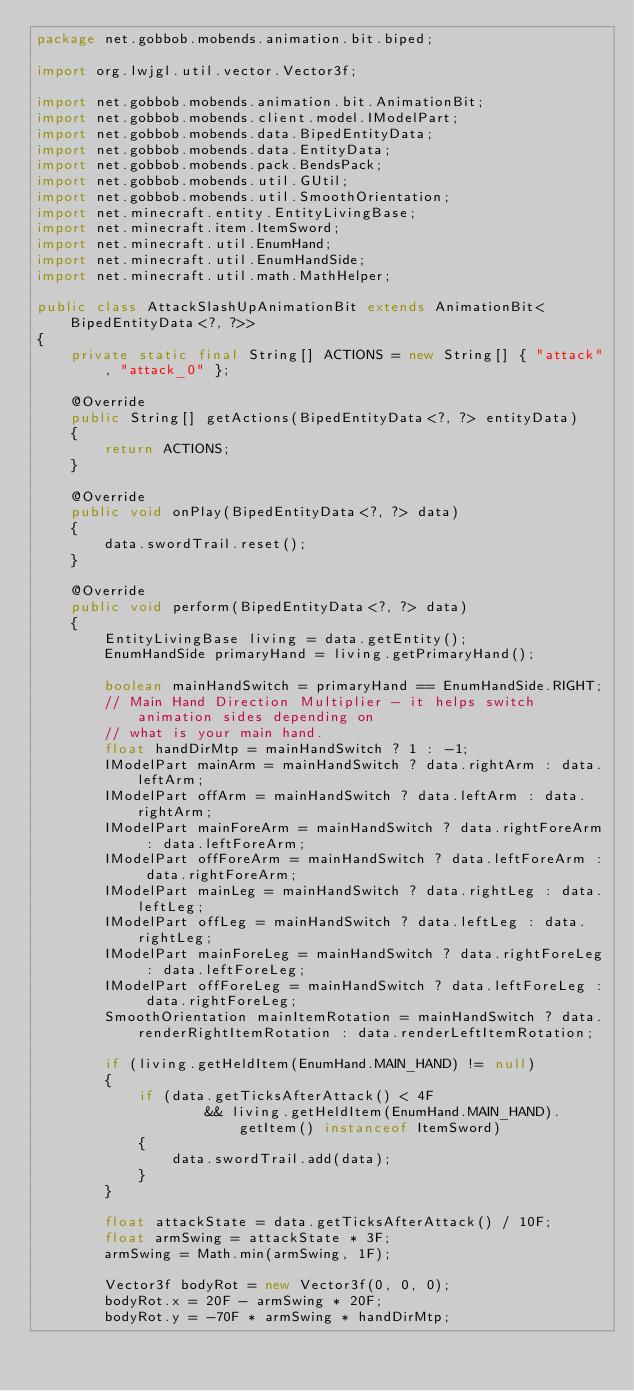<code> <loc_0><loc_0><loc_500><loc_500><_Java_>package net.gobbob.mobends.animation.bit.biped;

import org.lwjgl.util.vector.Vector3f;

import net.gobbob.mobends.animation.bit.AnimationBit;
import net.gobbob.mobends.client.model.IModelPart;
import net.gobbob.mobends.data.BipedEntityData;
import net.gobbob.mobends.data.EntityData;
import net.gobbob.mobends.pack.BendsPack;
import net.gobbob.mobends.util.GUtil;
import net.gobbob.mobends.util.SmoothOrientation;
import net.minecraft.entity.EntityLivingBase;
import net.minecraft.item.ItemSword;
import net.minecraft.util.EnumHand;
import net.minecraft.util.EnumHandSide;
import net.minecraft.util.math.MathHelper;

public class AttackSlashUpAnimationBit extends AnimationBit<BipedEntityData<?, ?>>
{
	private static final String[] ACTIONS = new String[] { "attack", "attack_0" };
	
	@Override
	public String[] getActions(BipedEntityData<?, ?> entityData)
	{
		return ACTIONS;
	}
	
	@Override
	public void onPlay(BipedEntityData<?, ?> data)
	{
		data.swordTrail.reset();
	}
	
	@Override
	public void perform(BipedEntityData<?, ?> data)
	{
		EntityLivingBase living = data.getEntity();
		EnumHandSide primaryHand = living.getPrimaryHand();

		boolean mainHandSwitch = primaryHand == EnumHandSide.RIGHT;
		// Main Hand Direction Multiplier - it helps switch animation sides depending on
		// what is your main hand.
		float handDirMtp = mainHandSwitch ? 1 : -1;
		IModelPart mainArm = mainHandSwitch ? data.rightArm : data.leftArm;
		IModelPart offArm = mainHandSwitch ? data.leftArm : data.rightArm;
		IModelPart mainForeArm = mainHandSwitch ? data.rightForeArm : data.leftForeArm;
		IModelPart offForeArm = mainHandSwitch ? data.leftForeArm : data.rightForeArm;
		IModelPart mainLeg = mainHandSwitch ? data.rightLeg : data.leftLeg;
		IModelPart offLeg = mainHandSwitch ? data.leftLeg : data.rightLeg;
		IModelPart mainForeLeg = mainHandSwitch ? data.rightForeLeg : data.leftForeLeg;
		IModelPart offForeLeg = mainHandSwitch ? data.leftForeLeg : data.rightForeLeg;
		SmoothOrientation mainItemRotation = mainHandSwitch ? data.renderRightItemRotation : data.renderLeftItemRotation;
		
		if (living.getHeldItem(EnumHand.MAIN_HAND) != null)
		{
			if (data.getTicksAfterAttack() < 4F
					&& living.getHeldItem(EnumHand.MAIN_HAND).getItem() instanceof ItemSword)
			{
				data.swordTrail.add(data);
			}
		}

		float attackState = data.getTicksAfterAttack() / 10F;
		float armSwing = attackState * 3F;
		armSwing = Math.min(armSwing, 1F);

		Vector3f bodyRot = new Vector3f(0, 0, 0);
		bodyRot.x = 20F - armSwing * 20F;
		bodyRot.y = -70F * armSwing * handDirMtp;
</code> 